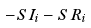<formula> <loc_0><loc_0><loc_500><loc_500>- S \, I _ { i } - S \, R _ { i }</formula> 